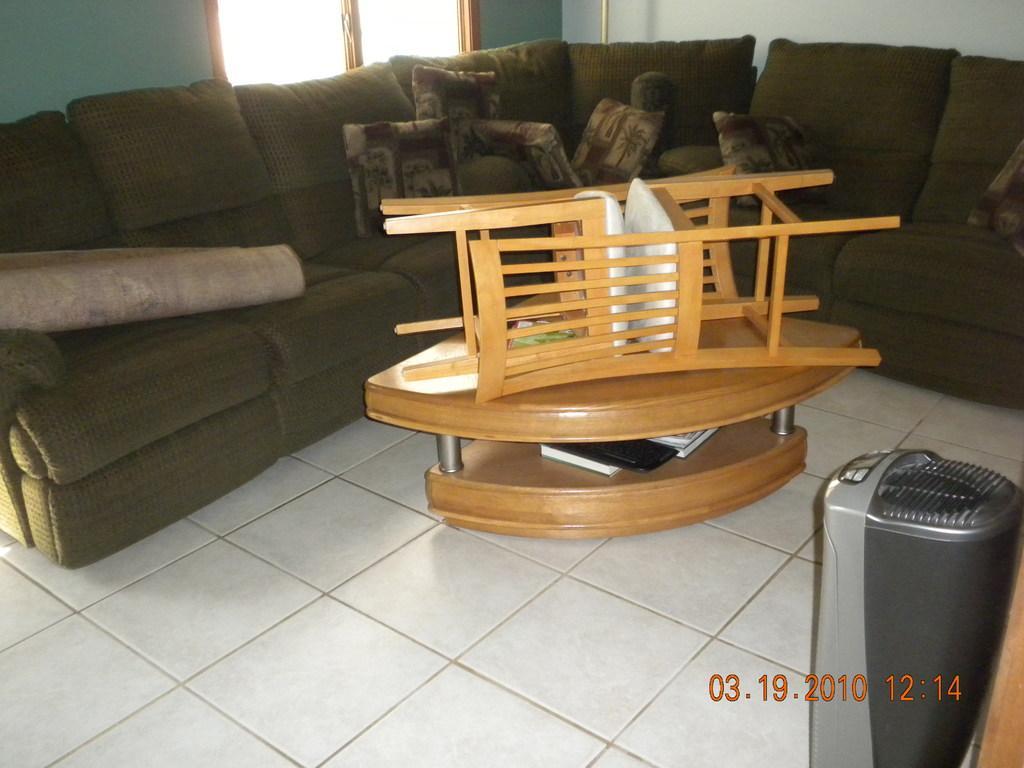In one or two sentences, can you explain what this image depicts? There is a sofa and these are the pillows. This is floor and there is a table. These are the chairs. On the background there is a wall and this is window. 